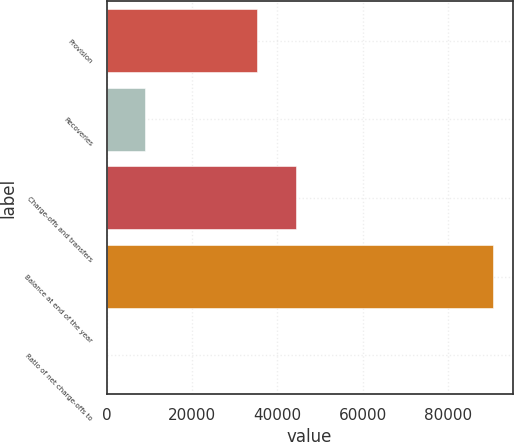Convert chart. <chart><loc_0><loc_0><loc_500><loc_500><bar_chart><fcel>Provision<fcel>Recoveries<fcel>Charge-offs and transfers<fcel>Balance at end of the year<fcel>Ratio of net charge-offs to<nl><fcel>35200<fcel>9054.06<fcel>44248.1<fcel>90487<fcel>5.96<nl></chart> 